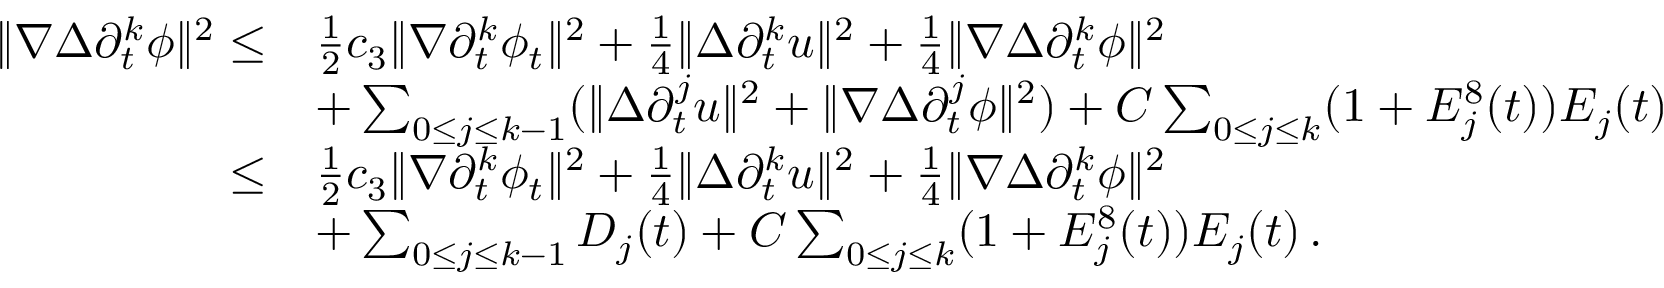<formula> <loc_0><loc_0><loc_500><loc_500>\begin{array} { r l } { \| \nabla \Delta \partial _ { t } ^ { k } \phi \| ^ { 2 } \leq } & { \frac { 1 } { 2 } c _ { 3 } \| \nabla \partial _ { t } ^ { k } \phi _ { t } \| ^ { 2 } + \frac { 1 } { 4 } \| \Delta \partial _ { t } ^ { k } u \| ^ { 2 } + \frac { 1 } { 4 } \| \nabla \Delta \partial _ { t } ^ { k } \phi \| ^ { 2 } } \\ & { + \sum _ { 0 \leq j \leq k - 1 } ( \| \Delta \partial _ { t } ^ { j } u \| ^ { 2 } + \| \nabla \Delta \partial _ { t } ^ { j } \phi \| ^ { 2 } ) + C \sum _ { 0 \leq j \leq k } ( 1 + E _ { j } ^ { 8 } ( t ) ) E _ { j } ( t ) } \\ { \leq } & { \frac { 1 } { 2 } c _ { 3 } \| \nabla \partial _ { t } ^ { k } \phi _ { t } \| ^ { 2 } + \frac { 1 } { 4 } \| \Delta \partial _ { t } ^ { k } u \| ^ { 2 } + \frac { 1 } { 4 } \| \nabla \Delta \partial _ { t } ^ { k } \phi \| ^ { 2 } } \\ & { + \sum _ { 0 \leq j \leq k - 1 } D _ { j } ( t ) + C \sum _ { 0 \leq j \leq k } ( 1 + E _ { j } ^ { 8 } ( t ) ) E _ { j } ( t ) \, . } \end{array}</formula> 